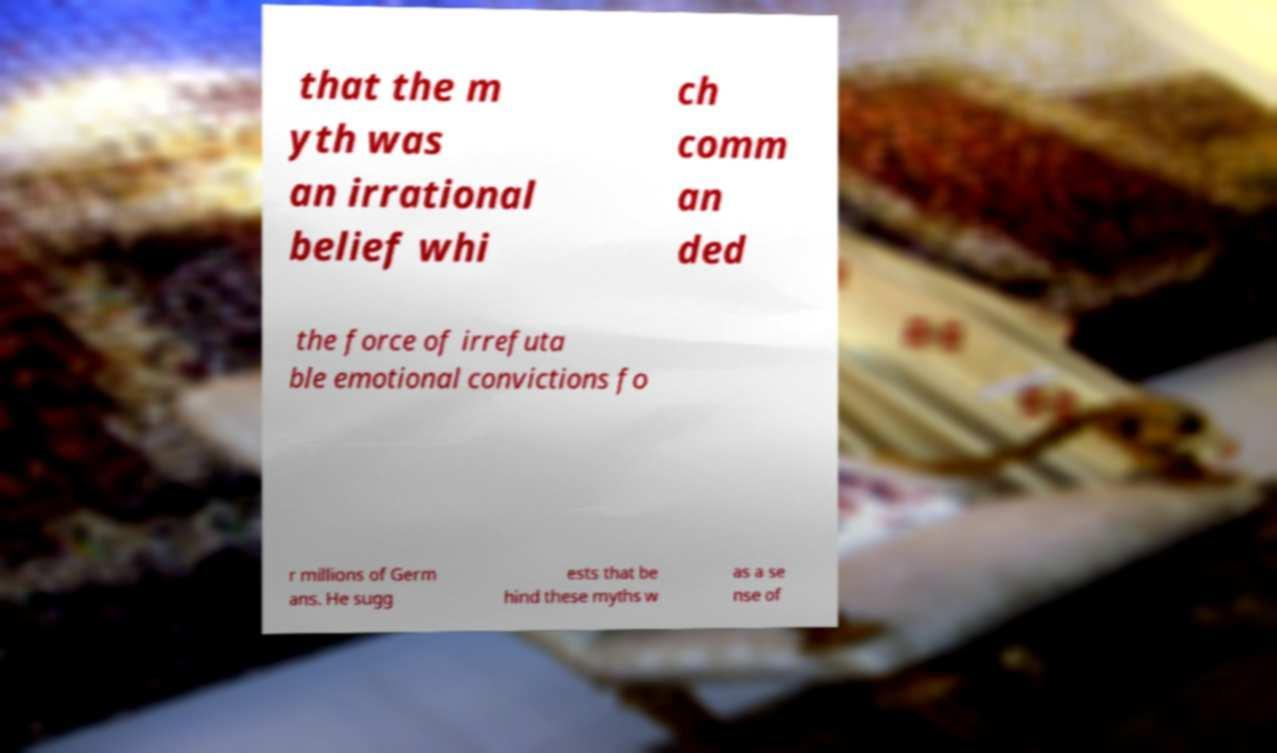Could you extract and type out the text from this image? that the m yth was an irrational belief whi ch comm an ded the force of irrefuta ble emotional convictions fo r millions of Germ ans. He sugg ests that be hind these myths w as a se nse of 